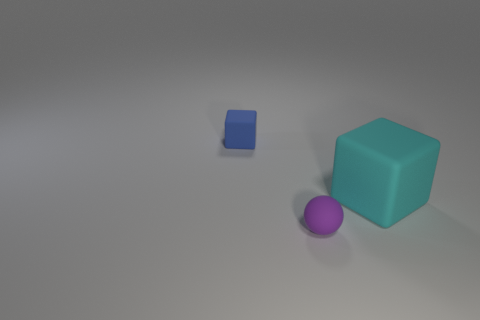There is a blue rubber thing; is its shape the same as the cyan matte thing that is behind the small purple rubber ball?
Your answer should be compact. Yes. The rubber object that is behind the ball and to the left of the large cyan cube has what shape?
Your response must be concise. Cube. Are there the same number of matte things left of the blue object and big cyan rubber blocks behind the big object?
Your response must be concise. Yes. Is the shape of the big cyan matte object that is on the right side of the small blue block the same as  the blue rubber thing?
Your answer should be compact. Yes. How many gray objects are matte balls or big blocks?
Keep it short and to the point. 0. There is another thing that is the same shape as the large cyan matte thing; what is it made of?
Your response must be concise. Rubber. There is a tiny thing in front of the big rubber thing; what is its shape?
Offer a terse response. Sphere. Are there any spheres that have the same material as the large cyan cube?
Your response must be concise. Yes. Do the rubber ball and the cyan rubber object have the same size?
Your response must be concise. No. How many spheres are either large yellow shiny objects or tiny things?
Make the answer very short. 1. 